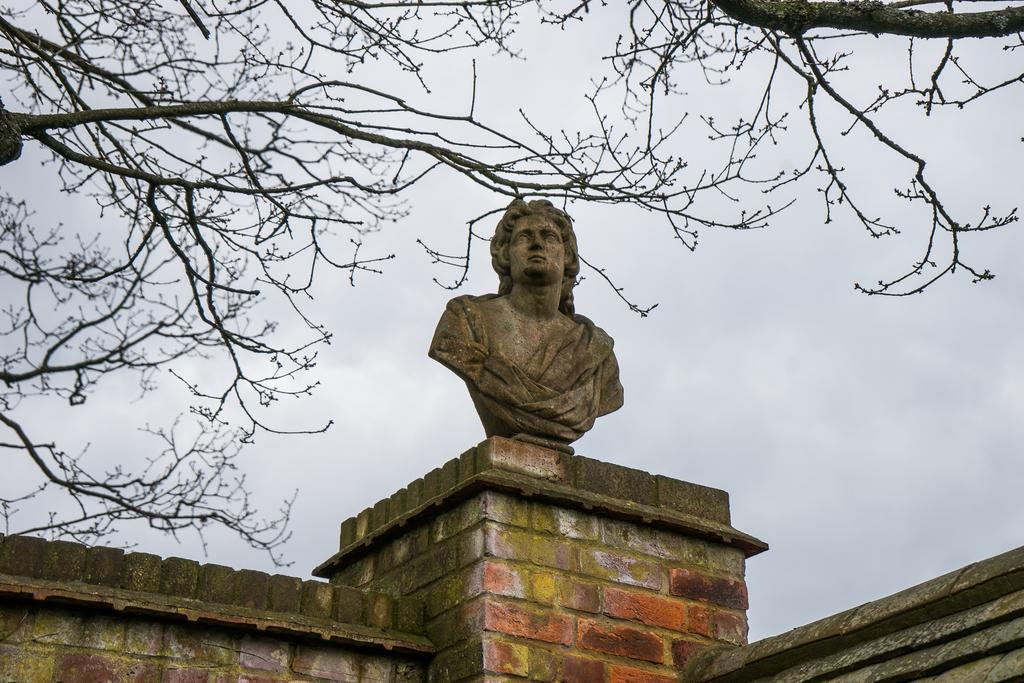Can you describe this image briefly? In this picture we can see a statue on the wall and in the background we can see trees, sky. 